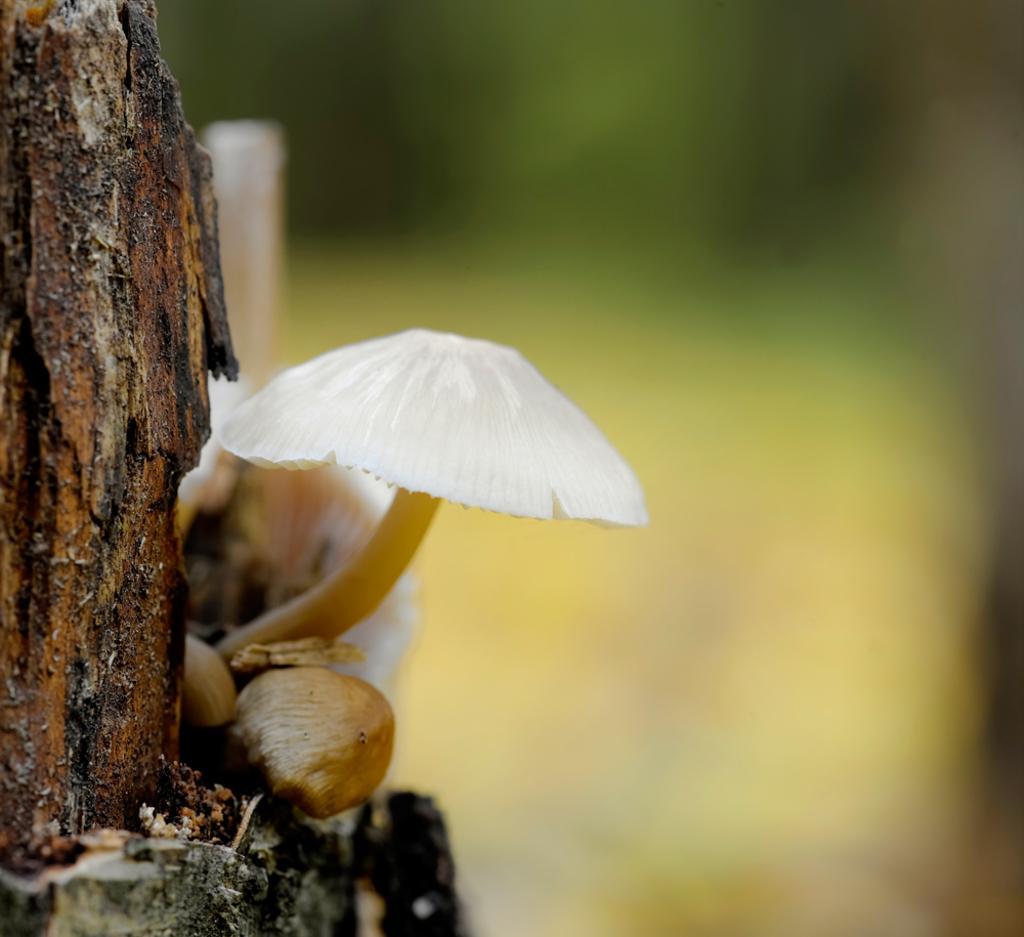Could you give a brief overview of what you see in this image? In this image there is mushroom on a wooden trunk, in the background it is blurred. 